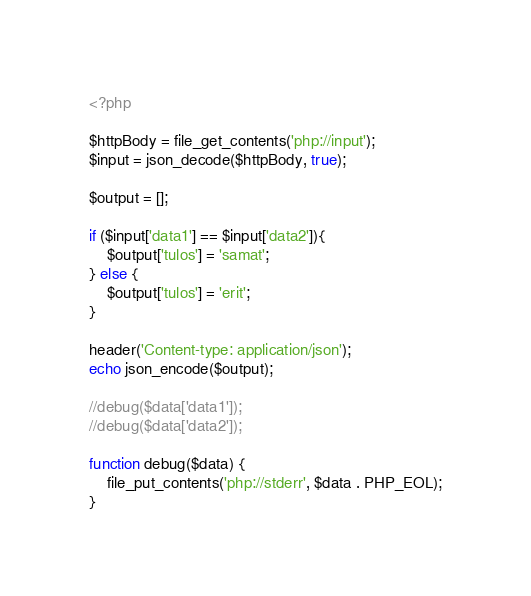<code> <loc_0><loc_0><loc_500><loc_500><_PHP_><?php

$httpBody = file_get_contents('php://input');
$input = json_decode($httpBody, true);

$output = [];

if ($input['data1'] == $input['data2']){
    $output['tulos'] = 'samat';
} else {
    $output['tulos'] = 'erit';
}

header('Content-type: application/json');
echo json_encode($output);

//debug($data['data1']);
//debug($data['data2']);

function debug($data) {
    file_put_contents('php://stderr', $data . PHP_EOL);
}
</code> 